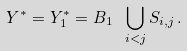Convert formula to latex. <formula><loc_0><loc_0><loc_500><loc_500>Y ^ { * } = Y ^ { * } _ { 1 } = B _ { 1 } \ \bigcup _ { i < j } S _ { i , j } \, .</formula> 